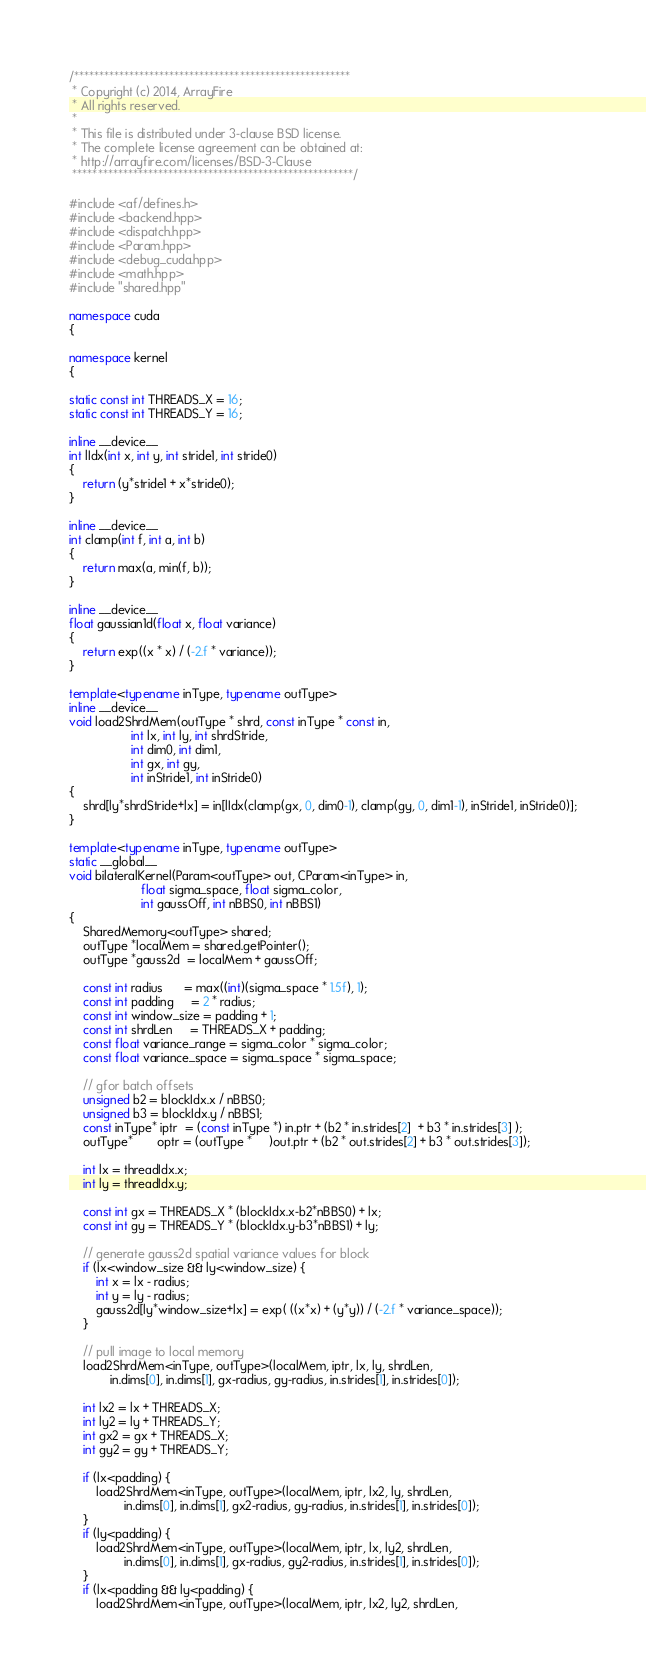Convert code to text. <code><loc_0><loc_0><loc_500><loc_500><_C++_>/*******************************************************
 * Copyright (c) 2014, ArrayFire
 * All rights reserved.
 *
 * This file is distributed under 3-clause BSD license.
 * The complete license agreement can be obtained at:
 * http://arrayfire.com/licenses/BSD-3-Clause
 ********************************************************/

#include <af/defines.h>
#include <backend.hpp>
#include <dispatch.hpp>
#include <Param.hpp>
#include <debug_cuda.hpp>
#include <math.hpp>
#include "shared.hpp"

namespace cuda
{

namespace kernel
{

static const int THREADS_X = 16;
static const int THREADS_Y = 16;

inline __device__
int lIdx(int x, int y, int stride1, int stride0)
{
    return (y*stride1 + x*stride0);
}

inline __device__
int clamp(int f, int a, int b)
{
    return max(a, min(f, b));
}

inline __device__
float gaussian1d(float x, float variance)
{
    return exp((x * x) / (-2.f * variance));
}

template<typename inType, typename outType>
inline __device__
void load2ShrdMem(outType * shrd, const inType * const in,
                  int lx, int ly, int shrdStride,
                  int dim0, int dim1,
                  int gx, int gy,
                  int inStride1, int inStride0)
{
    shrd[ly*shrdStride+lx] = in[lIdx(clamp(gx, 0, dim0-1), clamp(gy, 0, dim1-1), inStride1, inStride0)];
}

template<typename inType, typename outType>
static __global__
void bilateralKernel(Param<outType> out, CParam<inType> in,
                     float sigma_space, float sigma_color,
                     int gaussOff, int nBBS0, int nBBS1)
{
    SharedMemory<outType> shared;
    outType *localMem = shared.getPointer();
    outType *gauss2d  = localMem + gaussOff;

    const int radius      = max((int)(sigma_space * 1.5f), 1);
    const int padding     = 2 * radius;
    const int window_size = padding + 1;
    const int shrdLen     = THREADS_X + padding;
    const float variance_range = sigma_color * sigma_color;
    const float variance_space = sigma_space * sigma_space;

    // gfor batch offsets
    unsigned b2 = blockIdx.x / nBBS0;
    unsigned b3 = blockIdx.y / nBBS1;
    const inType* iptr  = (const inType *) in.ptr + (b2 * in.strides[2]  + b3 * in.strides[3] );
    outType*       optr = (outType *     )out.ptr + (b2 * out.strides[2] + b3 * out.strides[3]);

    int lx = threadIdx.x;
    int ly = threadIdx.y;

    const int gx = THREADS_X * (blockIdx.x-b2*nBBS0) + lx;
    const int gy = THREADS_Y * (blockIdx.y-b3*nBBS1) + ly;

    // generate gauss2d spatial variance values for block
    if (lx<window_size && ly<window_size) {
        int x = lx - radius;
        int y = ly - radius;
        gauss2d[ly*window_size+lx] = exp( ((x*x) + (y*y)) / (-2.f * variance_space));
    }

    // pull image to local memory
    load2ShrdMem<inType, outType>(localMem, iptr, lx, ly, shrdLen,
            in.dims[0], in.dims[1], gx-radius, gy-radius, in.strides[1], in.strides[0]);

    int lx2 = lx + THREADS_X;
    int ly2 = ly + THREADS_Y;
    int gx2 = gx + THREADS_X;
    int gy2 = gy + THREADS_Y;

    if (lx<padding) {
        load2ShrdMem<inType, outType>(localMem, iptr, lx2, ly, shrdLen,
                in.dims[0], in.dims[1], gx2-radius, gy-radius, in.strides[1], in.strides[0]);
    }
    if (ly<padding) {
        load2ShrdMem<inType, outType>(localMem, iptr, lx, ly2, shrdLen,
                in.dims[0], in.dims[1], gx-radius, gy2-radius, in.strides[1], in.strides[0]);
    }
    if (lx<padding && ly<padding) {
        load2ShrdMem<inType, outType>(localMem, iptr, lx2, ly2, shrdLen,</code> 